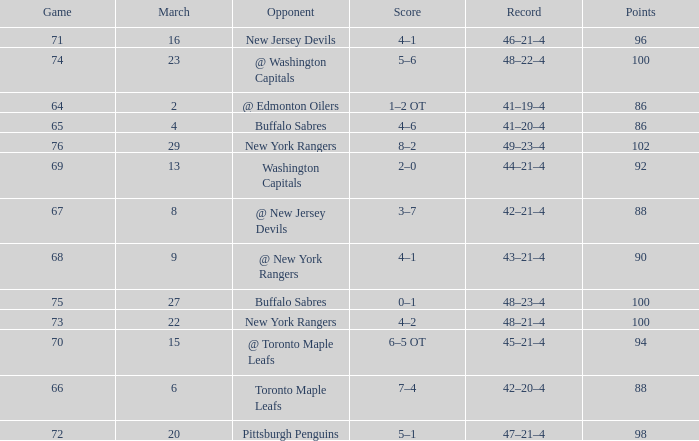Which March is the lowest one that has a Score of 5–6, and Points smaller than 100? None. 